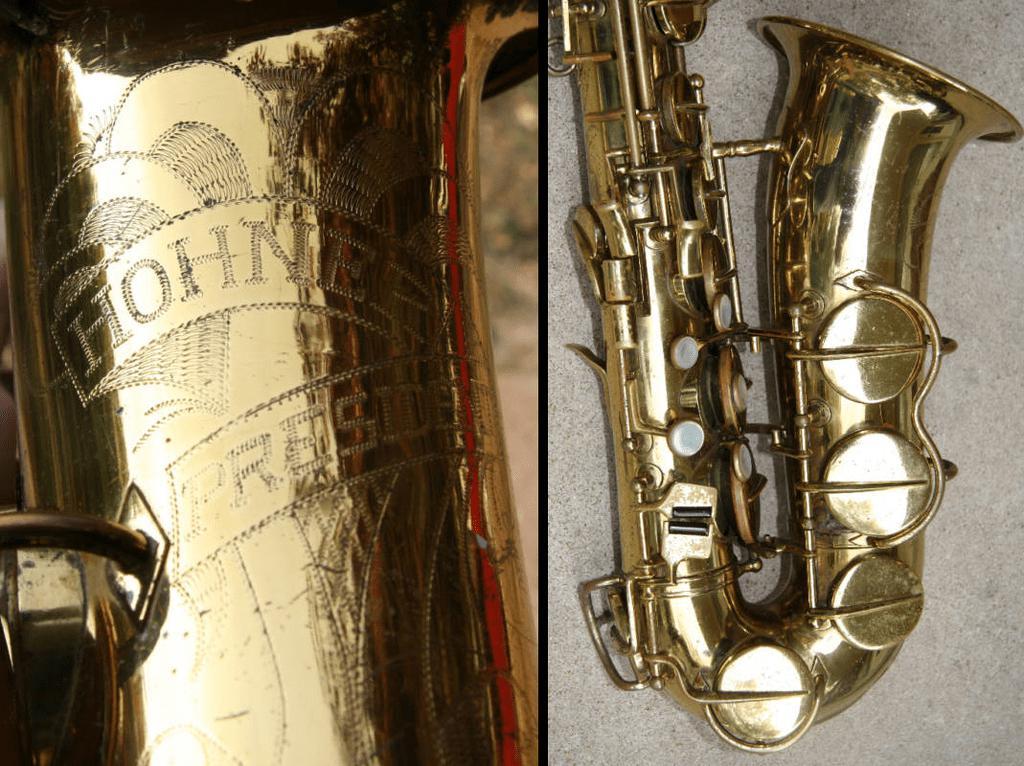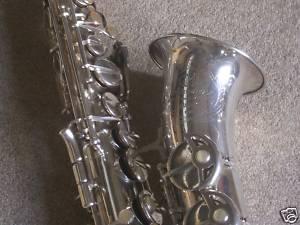The first image is the image on the left, the second image is the image on the right. Assess this claim about the two images: "The left sax is gold and the right one is silver.". Correct or not? Answer yes or no. Yes. The first image is the image on the left, the second image is the image on the right. For the images displayed, is the sentence "A total of two saxophones are shown, and one saxophone is displayed on some type of red fabric." factually correct? Answer yes or no. No. 